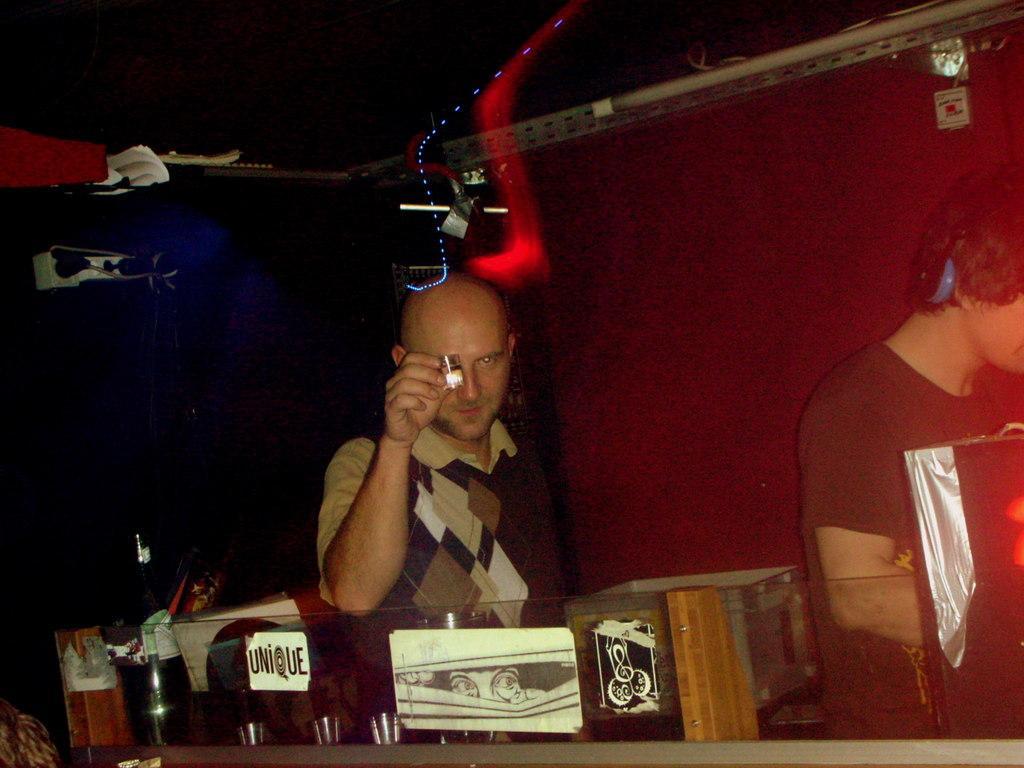Please provide a concise description of this image. In the image in the center we can see two persons were standing and they were holding some objects. In front of them,there is a table,glasses,banners etc. In the background there is a wall,roof,light,machine and few other objects. 